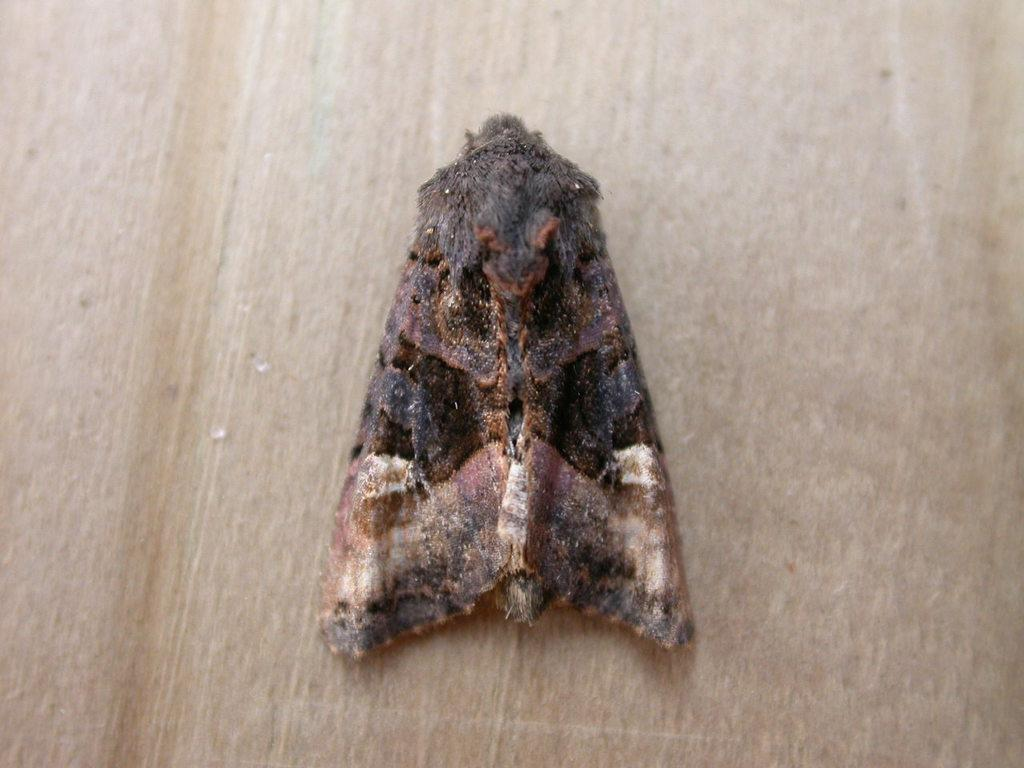What type of animal can be seen in the image? There is an insect in the image. Can you identify the specific type of insect in the image? The insect is a moth. What surface is the moth resting on in the image? The moth is on a wooden object. What type of love can be seen between the moth and the wooden object in the image? There is no indication of love or any emotional connection between the moth and the wooden object in the image. Can you describe the line that the moth is following in the image? There is no line present in the image, nor is the moth following any specific path. 